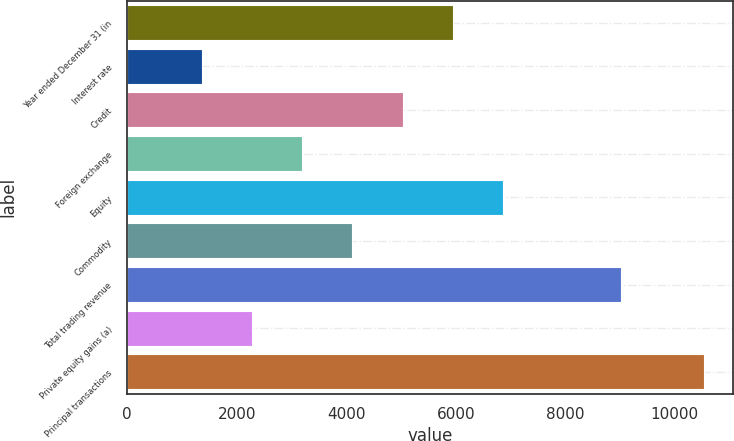<chart> <loc_0><loc_0><loc_500><loc_500><bar_chart><fcel>Year ended December 31 (in<fcel>Interest rate<fcel>Credit<fcel>Foreign exchange<fcel>Equity<fcel>Commodity<fcel>Total trading revenue<fcel>Private equity gains (a)<fcel>Principal transactions<nl><fcel>5946.5<fcel>1362<fcel>5029.6<fcel>3195.8<fcel>6863.4<fcel>4112.7<fcel>9024<fcel>2278.9<fcel>10531<nl></chart> 